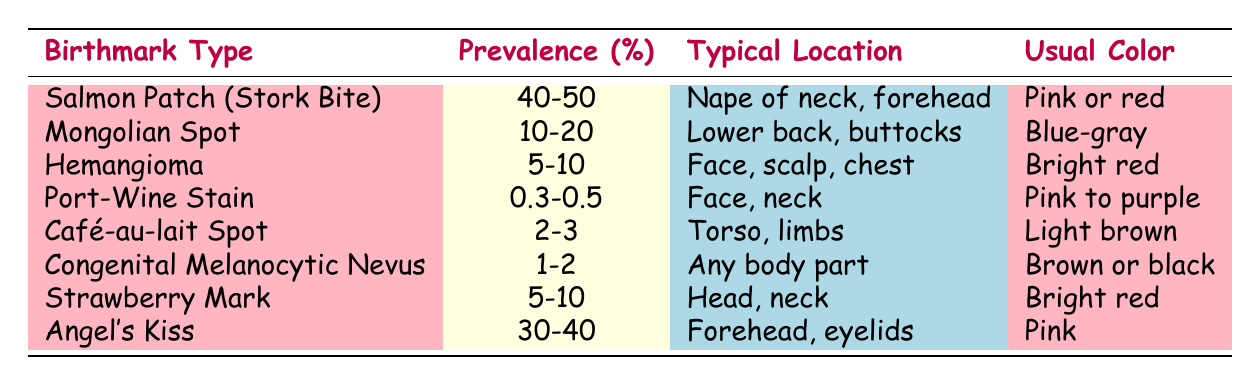What is the most prevalent type of birthmark in infants? The most prevalent type of birthmark listed in the table is the Salmon Patch (Stork Bite), which has a prevalence of 40-50%.
Answer: Salmon Patch (Stork Bite) What color is the Mongolian Spot? The table states that the Mongolian Spot is a blue-gray color.
Answer: Blue-gray How many birthmarks have a prevalence of 5-10%? The table lists three birthmarks (Hemangioma, Strawberry Mark) with a prevalence of 5-10%, and one additional one that is typically at the edge (Strawberry Mark). Counting those gives us three.
Answer: 3 Is the Port-Wine Stain more or less prevalent than the Café-au-lait Spot? The Port-Wine Stain has a prevalence of 0.3-0.5% while the Café-au-lait Spot has a prevalence of 2-3%. Since 2-3% is greater than 0.3-0.5%, the statement is true: the Port-Wine Stain is less prevalent.
Answer: Yes What is the average prevalence of the birthmarks listed in the table? To calculate the average, we consider the prevalence ranges: convert to percentages (self-explanatory and treated as single values, i.e., 45%, 15%, 7.5%, 0.4%, 2.5%, 1.5%, 5%, 35%). Adding these values results in 107.5% and dividing by 8 gives an average of approximately 13.44%.
Answer: 13.44% Which birthmark typically appears on the forehead and eyelids? According to the table, the Angel's Kiss typically appears on the forehead and eyelids.
Answer: Angel's Kiss Is it true that the Congenital Melanocytic Nevus can appear on any body part? The table specifies that the Congenital Melanocytic Nevus can appear on any body part, making this statement true.
Answer: Yes What are the usual colors for the birthmarks with the highest prevalence? The birthmarks with the highest prevalence are the Salmon Patch (Pink or red) and Angel's Kiss (Pink). Therefore, the usual colors are both pink.
Answer: Pink or red How does the prevalence of the Café-au-lait Spot compare to the Port-Wine Stain? The Café-au-lait Spot has a prevalence of 2-3%, while the Port-Wine Stain has a prevalence of 0.3-0.5%. Since 2-3% is greater than 0.3-0.5%, the Café-au-lait Spot is more prevalent than the Port-Wine Stain.
Answer: More prevalent 